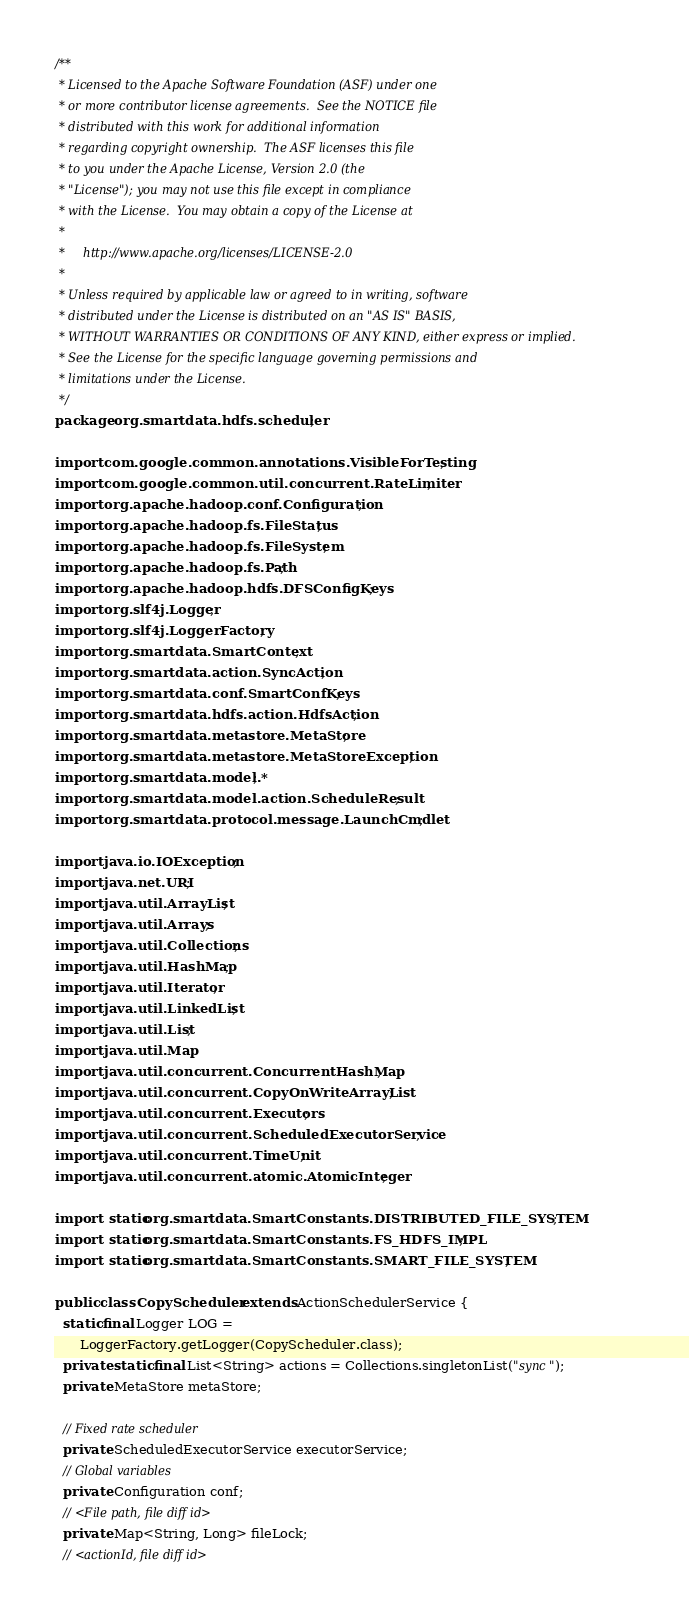<code> <loc_0><loc_0><loc_500><loc_500><_Java_>/**
 * Licensed to the Apache Software Foundation (ASF) under one
 * or more contributor license agreements.  See the NOTICE file
 * distributed with this work for additional information
 * regarding copyright ownership.  The ASF licenses this file
 * to you under the Apache License, Version 2.0 (the
 * "License"); you may not use this file except in compliance
 * with the License.  You may obtain a copy of the License at
 *
 *     http://www.apache.org/licenses/LICENSE-2.0
 *
 * Unless required by applicable law or agreed to in writing, software
 * distributed under the License is distributed on an "AS IS" BASIS,
 * WITHOUT WARRANTIES OR CONDITIONS OF ANY KIND, either express or implied.
 * See the License for the specific language governing permissions and
 * limitations under the License.
 */
package org.smartdata.hdfs.scheduler;

import com.google.common.annotations.VisibleForTesting;
import com.google.common.util.concurrent.RateLimiter;
import org.apache.hadoop.conf.Configuration;
import org.apache.hadoop.fs.FileStatus;
import org.apache.hadoop.fs.FileSystem;
import org.apache.hadoop.fs.Path;
import org.apache.hadoop.hdfs.DFSConfigKeys;
import org.slf4j.Logger;
import org.slf4j.LoggerFactory;
import org.smartdata.SmartContext;
import org.smartdata.action.SyncAction;
import org.smartdata.conf.SmartConfKeys;
import org.smartdata.hdfs.action.HdfsAction;
import org.smartdata.metastore.MetaStore;
import org.smartdata.metastore.MetaStoreException;
import org.smartdata.model.*;
import org.smartdata.model.action.ScheduleResult;
import org.smartdata.protocol.message.LaunchCmdlet;

import java.io.IOException;
import java.net.URI;
import java.util.ArrayList;
import java.util.Arrays;
import java.util.Collections;
import java.util.HashMap;
import java.util.Iterator;
import java.util.LinkedList;
import java.util.List;
import java.util.Map;
import java.util.concurrent.ConcurrentHashMap;
import java.util.concurrent.CopyOnWriteArrayList;
import java.util.concurrent.Executors;
import java.util.concurrent.ScheduledExecutorService;
import java.util.concurrent.TimeUnit;
import java.util.concurrent.atomic.AtomicInteger;

import static org.smartdata.SmartConstants.DISTRIBUTED_FILE_SYSTEM;
import static org.smartdata.SmartConstants.FS_HDFS_IMPL;
import static org.smartdata.SmartConstants.SMART_FILE_SYSTEM;

public class CopyScheduler extends ActionSchedulerService {
  static final Logger LOG =
      LoggerFactory.getLogger(CopyScheduler.class);
  private static final List<String> actions = Collections.singletonList("sync");
  private MetaStore metaStore;

  // Fixed rate scheduler
  private ScheduledExecutorService executorService;
  // Global variables
  private Configuration conf;
  // <File path, file diff id>
  private Map<String, Long> fileLock;
  // <actionId, file diff id></code> 